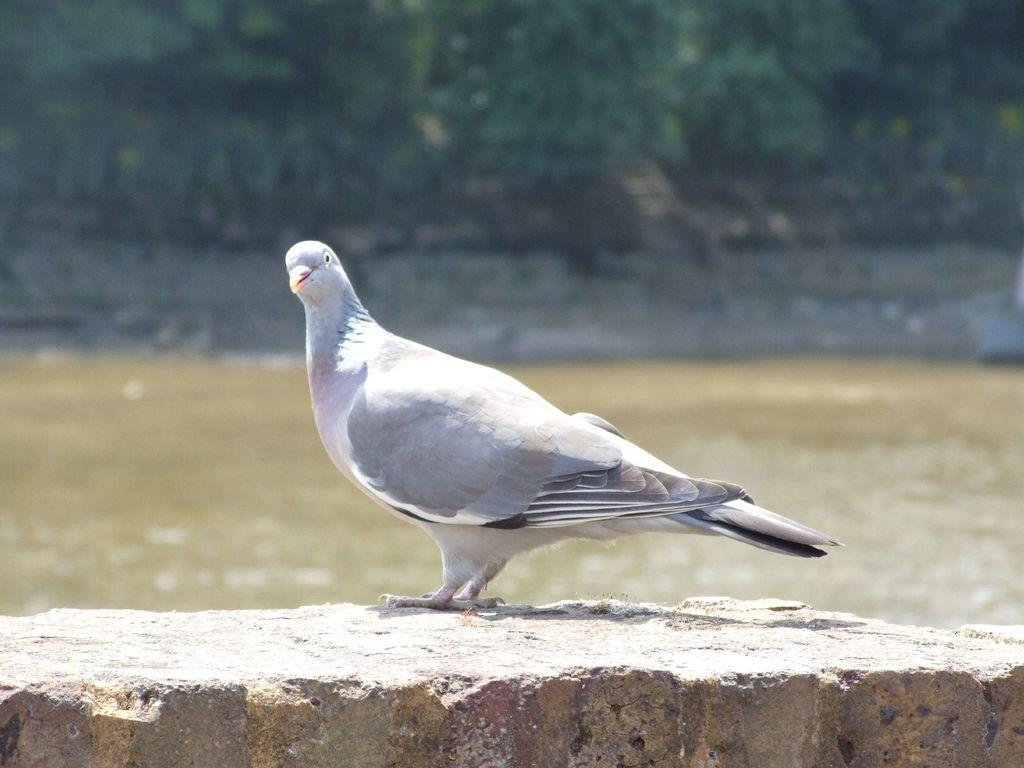What type of bird is in the image? There is a pigeon in the image. What color is the pigeon? The pigeon is gray in color. Where is the pigeon located in the image? The pigeon is standing on a wall. What else can be seen in the image besides the pigeon? There is water visible in the image, and there are plants, although they are not clearly visible. What time of day is depicted in the image? The time of day cannot be determined from the image, as there are no specific clues or indicators present. 